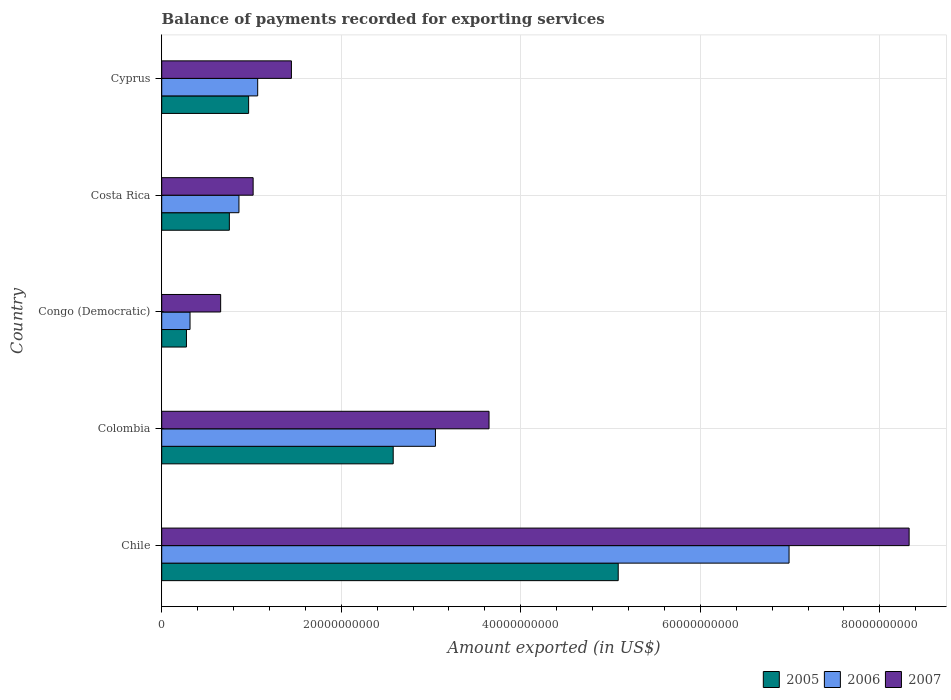How many different coloured bars are there?
Keep it short and to the point. 3. How many groups of bars are there?
Ensure brevity in your answer.  5. Are the number of bars per tick equal to the number of legend labels?
Your response must be concise. Yes. Are the number of bars on each tick of the Y-axis equal?
Your response must be concise. Yes. What is the label of the 4th group of bars from the top?
Keep it short and to the point. Colombia. What is the amount exported in 2005 in Colombia?
Your answer should be compact. 2.58e+1. Across all countries, what is the maximum amount exported in 2007?
Provide a short and direct response. 8.33e+1. Across all countries, what is the minimum amount exported in 2007?
Your answer should be very brief. 6.57e+09. In which country was the amount exported in 2007 maximum?
Your answer should be very brief. Chile. In which country was the amount exported in 2006 minimum?
Ensure brevity in your answer.  Congo (Democratic). What is the total amount exported in 2006 in the graph?
Provide a short and direct response. 1.23e+11. What is the difference between the amount exported in 2006 in Congo (Democratic) and that in Costa Rica?
Give a very brief answer. -5.45e+09. What is the difference between the amount exported in 2007 in Congo (Democratic) and the amount exported in 2005 in Colombia?
Ensure brevity in your answer.  -1.92e+1. What is the average amount exported in 2006 per country?
Offer a terse response. 2.46e+1. What is the difference between the amount exported in 2006 and amount exported in 2005 in Congo (Democratic)?
Your answer should be very brief. 4.00e+08. In how many countries, is the amount exported in 2007 greater than 72000000000 US$?
Offer a very short reply. 1. What is the ratio of the amount exported in 2007 in Colombia to that in Cyprus?
Offer a terse response. 2.52. Is the amount exported in 2006 in Chile less than that in Costa Rica?
Keep it short and to the point. No. Is the difference between the amount exported in 2006 in Costa Rica and Cyprus greater than the difference between the amount exported in 2005 in Costa Rica and Cyprus?
Your response must be concise. Yes. What is the difference between the highest and the second highest amount exported in 2006?
Offer a terse response. 3.94e+1. What is the difference between the highest and the lowest amount exported in 2005?
Offer a very short reply. 4.81e+1. In how many countries, is the amount exported in 2007 greater than the average amount exported in 2007 taken over all countries?
Provide a succinct answer. 2. Is it the case that in every country, the sum of the amount exported in 2007 and amount exported in 2005 is greater than the amount exported in 2006?
Make the answer very short. Yes. How many countries are there in the graph?
Keep it short and to the point. 5. What is the difference between two consecutive major ticks on the X-axis?
Provide a succinct answer. 2.00e+1. Does the graph contain any zero values?
Your answer should be very brief. No. How are the legend labels stacked?
Give a very brief answer. Horizontal. What is the title of the graph?
Make the answer very short. Balance of payments recorded for exporting services. What is the label or title of the X-axis?
Keep it short and to the point. Amount exported (in US$). What is the label or title of the Y-axis?
Provide a short and direct response. Country. What is the Amount exported (in US$) of 2005 in Chile?
Ensure brevity in your answer.  5.09e+1. What is the Amount exported (in US$) of 2006 in Chile?
Offer a very short reply. 6.99e+1. What is the Amount exported (in US$) in 2007 in Chile?
Provide a succinct answer. 8.33e+1. What is the Amount exported (in US$) of 2005 in Colombia?
Ensure brevity in your answer.  2.58e+1. What is the Amount exported (in US$) in 2006 in Colombia?
Keep it short and to the point. 3.05e+1. What is the Amount exported (in US$) of 2007 in Colombia?
Offer a terse response. 3.65e+1. What is the Amount exported (in US$) in 2005 in Congo (Democratic)?
Your answer should be very brief. 2.76e+09. What is the Amount exported (in US$) in 2006 in Congo (Democratic)?
Your answer should be compact. 3.16e+09. What is the Amount exported (in US$) in 2007 in Congo (Democratic)?
Your answer should be very brief. 6.57e+09. What is the Amount exported (in US$) of 2005 in Costa Rica?
Ensure brevity in your answer.  7.54e+09. What is the Amount exported (in US$) in 2006 in Costa Rica?
Keep it short and to the point. 8.60e+09. What is the Amount exported (in US$) in 2007 in Costa Rica?
Make the answer very short. 1.02e+1. What is the Amount exported (in US$) in 2005 in Cyprus?
Keep it short and to the point. 9.68e+09. What is the Amount exported (in US$) in 2006 in Cyprus?
Provide a succinct answer. 1.07e+1. What is the Amount exported (in US$) in 2007 in Cyprus?
Keep it short and to the point. 1.44e+1. Across all countries, what is the maximum Amount exported (in US$) in 2005?
Make the answer very short. 5.09e+1. Across all countries, what is the maximum Amount exported (in US$) in 2006?
Provide a short and direct response. 6.99e+1. Across all countries, what is the maximum Amount exported (in US$) of 2007?
Offer a very short reply. 8.33e+1. Across all countries, what is the minimum Amount exported (in US$) of 2005?
Offer a very short reply. 2.76e+09. Across all countries, what is the minimum Amount exported (in US$) in 2006?
Ensure brevity in your answer.  3.16e+09. Across all countries, what is the minimum Amount exported (in US$) of 2007?
Your answer should be very brief. 6.57e+09. What is the total Amount exported (in US$) of 2005 in the graph?
Make the answer very short. 9.66e+1. What is the total Amount exported (in US$) in 2006 in the graph?
Offer a very short reply. 1.23e+11. What is the total Amount exported (in US$) in 2007 in the graph?
Ensure brevity in your answer.  1.51e+11. What is the difference between the Amount exported (in US$) of 2005 in Chile and that in Colombia?
Offer a very short reply. 2.51e+1. What is the difference between the Amount exported (in US$) of 2006 in Chile and that in Colombia?
Offer a very short reply. 3.94e+1. What is the difference between the Amount exported (in US$) of 2007 in Chile and that in Colombia?
Make the answer very short. 4.68e+1. What is the difference between the Amount exported (in US$) in 2005 in Chile and that in Congo (Democratic)?
Offer a terse response. 4.81e+1. What is the difference between the Amount exported (in US$) in 2006 in Chile and that in Congo (Democratic)?
Make the answer very short. 6.67e+1. What is the difference between the Amount exported (in US$) of 2007 in Chile and that in Congo (Democratic)?
Ensure brevity in your answer.  7.67e+1. What is the difference between the Amount exported (in US$) of 2005 in Chile and that in Costa Rica?
Ensure brevity in your answer.  4.33e+1. What is the difference between the Amount exported (in US$) in 2006 in Chile and that in Costa Rica?
Keep it short and to the point. 6.13e+1. What is the difference between the Amount exported (in US$) of 2007 in Chile and that in Costa Rica?
Offer a terse response. 7.31e+1. What is the difference between the Amount exported (in US$) in 2005 in Chile and that in Cyprus?
Provide a short and direct response. 4.12e+1. What is the difference between the Amount exported (in US$) in 2006 in Chile and that in Cyprus?
Give a very brief answer. 5.92e+1. What is the difference between the Amount exported (in US$) of 2007 in Chile and that in Cyprus?
Provide a succinct answer. 6.88e+1. What is the difference between the Amount exported (in US$) in 2005 in Colombia and that in Congo (Democratic)?
Your answer should be compact. 2.30e+1. What is the difference between the Amount exported (in US$) of 2006 in Colombia and that in Congo (Democratic)?
Ensure brevity in your answer.  2.73e+1. What is the difference between the Amount exported (in US$) in 2007 in Colombia and that in Congo (Democratic)?
Give a very brief answer. 2.99e+1. What is the difference between the Amount exported (in US$) in 2005 in Colombia and that in Costa Rica?
Offer a terse response. 1.83e+1. What is the difference between the Amount exported (in US$) of 2006 in Colombia and that in Costa Rica?
Provide a short and direct response. 2.19e+1. What is the difference between the Amount exported (in US$) of 2007 in Colombia and that in Costa Rica?
Offer a terse response. 2.63e+1. What is the difference between the Amount exported (in US$) of 2005 in Colombia and that in Cyprus?
Give a very brief answer. 1.61e+1. What is the difference between the Amount exported (in US$) in 2006 in Colombia and that in Cyprus?
Give a very brief answer. 1.98e+1. What is the difference between the Amount exported (in US$) in 2007 in Colombia and that in Cyprus?
Ensure brevity in your answer.  2.20e+1. What is the difference between the Amount exported (in US$) in 2005 in Congo (Democratic) and that in Costa Rica?
Make the answer very short. -4.78e+09. What is the difference between the Amount exported (in US$) of 2006 in Congo (Democratic) and that in Costa Rica?
Keep it short and to the point. -5.45e+09. What is the difference between the Amount exported (in US$) of 2007 in Congo (Democratic) and that in Costa Rica?
Your response must be concise. -3.62e+09. What is the difference between the Amount exported (in US$) in 2005 in Congo (Democratic) and that in Cyprus?
Make the answer very short. -6.93e+09. What is the difference between the Amount exported (in US$) of 2006 in Congo (Democratic) and that in Cyprus?
Provide a succinct answer. -7.54e+09. What is the difference between the Amount exported (in US$) of 2007 in Congo (Democratic) and that in Cyprus?
Keep it short and to the point. -7.88e+09. What is the difference between the Amount exported (in US$) of 2005 in Costa Rica and that in Cyprus?
Ensure brevity in your answer.  -2.15e+09. What is the difference between the Amount exported (in US$) in 2006 in Costa Rica and that in Cyprus?
Your answer should be very brief. -2.09e+09. What is the difference between the Amount exported (in US$) of 2007 in Costa Rica and that in Cyprus?
Keep it short and to the point. -4.27e+09. What is the difference between the Amount exported (in US$) of 2005 in Chile and the Amount exported (in US$) of 2006 in Colombia?
Provide a short and direct response. 2.04e+1. What is the difference between the Amount exported (in US$) in 2005 in Chile and the Amount exported (in US$) in 2007 in Colombia?
Provide a short and direct response. 1.44e+1. What is the difference between the Amount exported (in US$) of 2006 in Chile and the Amount exported (in US$) of 2007 in Colombia?
Give a very brief answer. 3.34e+1. What is the difference between the Amount exported (in US$) in 2005 in Chile and the Amount exported (in US$) in 2006 in Congo (Democratic)?
Your answer should be very brief. 4.77e+1. What is the difference between the Amount exported (in US$) in 2005 in Chile and the Amount exported (in US$) in 2007 in Congo (Democratic)?
Your answer should be very brief. 4.43e+1. What is the difference between the Amount exported (in US$) in 2006 in Chile and the Amount exported (in US$) in 2007 in Congo (Democratic)?
Your answer should be compact. 6.33e+1. What is the difference between the Amount exported (in US$) of 2005 in Chile and the Amount exported (in US$) of 2006 in Costa Rica?
Give a very brief answer. 4.22e+1. What is the difference between the Amount exported (in US$) of 2005 in Chile and the Amount exported (in US$) of 2007 in Costa Rica?
Provide a succinct answer. 4.07e+1. What is the difference between the Amount exported (in US$) of 2006 in Chile and the Amount exported (in US$) of 2007 in Costa Rica?
Your response must be concise. 5.97e+1. What is the difference between the Amount exported (in US$) of 2005 in Chile and the Amount exported (in US$) of 2006 in Cyprus?
Ensure brevity in your answer.  4.02e+1. What is the difference between the Amount exported (in US$) of 2005 in Chile and the Amount exported (in US$) of 2007 in Cyprus?
Keep it short and to the point. 3.64e+1. What is the difference between the Amount exported (in US$) of 2006 in Chile and the Amount exported (in US$) of 2007 in Cyprus?
Give a very brief answer. 5.54e+1. What is the difference between the Amount exported (in US$) of 2005 in Colombia and the Amount exported (in US$) of 2006 in Congo (Democratic)?
Offer a very short reply. 2.26e+1. What is the difference between the Amount exported (in US$) in 2005 in Colombia and the Amount exported (in US$) in 2007 in Congo (Democratic)?
Offer a very short reply. 1.92e+1. What is the difference between the Amount exported (in US$) of 2006 in Colombia and the Amount exported (in US$) of 2007 in Congo (Democratic)?
Your answer should be compact. 2.39e+1. What is the difference between the Amount exported (in US$) of 2005 in Colombia and the Amount exported (in US$) of 2006 in Costa Rica?
Provide a short and direct response. 1.72e+1. What is the difference between the Amount exported (in US$) in 2005 in Colombia and the Amount exported (in US$) in 2007 in Costa Rica?
Your answer should be very brief. 1.56e+1. What is the difference between the Amount exported (in US$) of 2006 in Colombia and the Amount exported (in US$) of 2007 in Costa Rica?
Your answer should be compact. 2.03e+1. What is the difference between the Amount exported (in US$) of 2005 in Colombia and the Amount exported (in US$) of 2006 in Cyprus?
Make the answer very short. 1.51e+1. What is the difference between the Amount exported (in US$) of 2005 in Colombia and the Amount exported (in US$) of 2007 in Cyprus?
Give a very brief answer. 1.13e+1. What is the difference between the Amount exported (in US$) in 2006 in Colombia and the Amount exported (in US$) in 2007 in Cyprus?
Keep it short and to the point. 1.60e+1. What is the difference between the Amount exported (in US$) in 2005 in Congo (Democratic) and the Amount exported (in US$) in 2006 in Costa Rica?
Ensure brevity in your answer.  -5.85e+09. What is the difference between the Amount exported (in US$) in 2005 in Congo (Democratic) and the Amount exported (in US$) in 2007 in Costa Rica?
Provide a short and direct response. -7.43e+09. What is the difference between the Amount exported (in US$) in 2006 in Congo (Democratic) and the Amount exported (in US$) in 2007 in Costa Rica?
Keep it short and to the point. -7.03e+09. What is the difference between the Amount exported (in US$) of 2005 in Congo (Democratic) and the Amount exported (in US$) of 2006 in Cyprus?
Your answer should be compact. -7.94e+09. What is the difference between the Amount exported (in US$) of 2005 in Congo (Democratic) and the Amount exported (in US$) of 2007 in Cyprus?
Ensure brevity in your answer.  -1.17e+1. What is the difference between the Amount exported (in US$) of 2006 in Congo (Democratic) and the Amount exported (in US$) of 2007 in Cyprus?
Provide a succinct answer. -1.13e+1. What is the difference between the Amount exported (in US$) of 2005 in Costa Rica and the Amount exported (in US$) of 2006 in Cyprus?
Provide a succinct answer. -3.16e+09. What is the difference between the Amount exported (in US$) of 2005 in Costa Rica and the Amount exported (in US$) of 2007 in Cyprus?
Provide a succinct answer. -6.91e+09. What is the difference between the Amount exported (in US$) in 2006 in Costa Rica and the Amount exported (in US$) in 2007 in Cyprus?
Ensure brevity in your answer.  -5.84e+09. What is the average Amount exported (in US$) in 2005 per country?
Offer a terse response. 1.93e+1. What is the average Amount exported (in US$) of 2006 per country?
Offer a terse response. 2.46e+1. What is the average Amount exported (in US$) in 2007 per country?
Keep it short and to the point. 3.02e+1. What is the difference between the Amount exported (in US$) in 2005 and Amount exported (in US$) in 2006 in Chile?
Offer a terse response. -1.90e+1. What is the difference between the Amount exported (in US$) of 2005 and Amount exported (in US$) of 2007 in Chile?
Offer a very short reply. -3.24e+1. What is the difference between the Amount exported (in US$) of 2006 and Amount exported (in US$) of 2007 in Chile?
Make the answer very short. -1.34e+1. What is the difference between the Amount exported (in US$) in 2005 and Amount exported (in US$) in 2006 in Colombia?
Provide a short and direct response. -4.70e+09. What is the difference between the Amount exported (in US$) in 2005 and Amount exported (in US$) in 2007 in Colombia?
Give a very brief answer. -1.07e+1. What is the difference between the Amount exported (in US$) of 2006 and Amount exported (in US$) of 2007 in Colombia?
Offer a very short reply. -5.97e+09. What is the difference between the Amount exported (in US$) in 2005 and Amount exported (in US$) in 2006 in Congo (Democratic)?
Give a very brief answer. -4.00e+08. What is the difference between the Amount exported (in US$) of 2005 and Amount exported (in US$) of 2007 in Congo (Democratic)?
Your response must be concise. -3.81e+09. What is the difference between the Amount exported (in US$) in 2006 and Amount exported (in US$) in 2007 in Congo (Democratic)?
Your answer should be compact. -3.41e+09. What is the difference between the Amount exported (in US$) in 2005 and Amount exported (in US$) in 2006 in Costa Rica?
Give a very brief answer. -1.07e+09. What is the difference between the Amount exported (in US$) in 2005 and Amount exported (in US$) in 2007 in Costa Rica?
Your response must be concise. -2.65e+09. What is the difference between the Amount exported (in US$) in 2006 and Amount exported (in US$) in 2007 in Costa Rica?
Provide a short and direct response. -1.58e+09. What is the difference between the Amount exported (in US$) of 2005 and Amount exported (in US$) of 2006 in Cyprus?
Your response must be concise. -1.01e+09. What is the difference between the Amount exported (in US$) in 2005 and Amount exported (in US$) in 2007 in Cyprus?
Keep it short and to the point. -4.77e+09. What is the difference between the Amount exported (in US$) in 2006 and Amount exported (in US$) in 2007 in Cyprus?
Keep it short and to the point. -3.76e+09. What is the ratio of the Amount exported (in US$) in 2005 in Chile to that in Colombia?
Ensure brevity in your answer.  1.97. What is the ratio of the Amount exported (in US$) in 2006 in Chile to that in Colombia?
Your response must be concise. 2.29. What is the ratio of the Amount exported (in US$) of 2007 in Chile to that in Colombia?
Offer a terse response. 2.28. What is the ratio of the Amount exported (in US$) in 2005 in Chile to that in Congo (Democratic)?
Provide a succinct answer. 18.46. What is the ratio of the Amount exported (in US$) in 2006 in Chile to that in Congo (Democratic)?
Provide a succinct answer. 22.15. What is the ratio of the Amount exported (in US$) of 2007 in Chile to that in Congo (Democratic)?
Ensure brevity in your answer.  12.68. What is the ratio of the Amount exported (in US$) in 2005 in Chile to that in Costa Rica?
Your answer should be compact. 6.75. What is the ratio of the Amount exported (in US$) in 2006 in Chile to that in Costa Rica?
Offer a very short reply. 8.12. What is the ratio of the Amount exported (in US$) of 2007 in Chile to that in Costa Rica?
Make the answer very short. 8.18. What is the ratio of the Amount exported (in US$) of 2005 in Chile to that in Cyprus?
Provide a succinct answer. 5.25. What is the ratio of the Amount exported (in US$) of 2006 in Chile to that in Cyprus?
Keep it short and to the point. 6.54. What is the ratio of the Amount exported (in US$) of 2007 in Chile to that in Cyprus?
Your response must be concise. 5.76. What is the ratio of the Amount exported (in US$) in 2005 in Colombia to that in Congo (Democratic)?
Make the answer very short. 9.36. What is the ratio of the Amount exported (in US$) of 2006 in Colombia to that in Congo (Democratic)?
Your response must be concise. 9.66. What is the ratio of the Amount exported (in US$) in 2007 in Colombia to that in Congo (Democratic)?
Your answer should be compact. 5.55. What is the ratio of the Amount exported (in US$) of 2005 in Colombia to that in Costa Rica?
Provide a short and direct response. 3.42. What is the ratio of the Amount exported (in US$) in 2006 in Colombia to that in Costa Rica?
Your answer should be very brief. 3.54. What is the ratio of the Amount exported (in US$) of 2007 in Colombia to that in Costa Rica?
Offer a very short reply. 3.58. What is the ratio of the Amount exported (in US$) of 2005 in Colombia to that in Cyprus?
Your answer should be very brief. 2.66. What is the ratio of the Amount exported (in US$) in 2006 in Colombia to that in Cyprus?
Your answer should be compact. 2.85. What is the ratio of the Amount exported (in US$) of 2007 in Colombia to that in Cyprus?
Your answer should be very brief. 2.52. What is the ratio of the Amount exported (in US$) in 2005 in Congo (Democratic) to that in Costa Rica?
Your response must be concise. 0.37. What is the ratio of the Amount exported (in US$) of 2006 in Congo (Democratic) to that in Costa Rica?
Keep it short and to the point. 0.37. What is the ratio of the Amount exported (in US$) in 2007 in Congo (Democratic) to that in Costa Rica?
Your response must be concise. 0.64. What is the ratio of the Amount exported (in US$) in 2005 in Congo (Democratic) to that in Cyprus?
Your answer should be compact. 0.28. What is the ratio of the Amount exported (in US$) of 2006 in Congo (Democratic) to that in Cyprus?
Offer a terse response. 0.3. What is the ratio of the Amount exported (in US$) of 2007 in Congo (Democratic) to that in Cyprus?
Offer a very short reply. 0.45. What is the ratio of the Amount exported (in US$) in 2005 in Costa Rica to that in Cyprus?
Provide a succinct answer. 0.78. What is the ratio of the Amount exported (in US$) in 2006 in Costa Rica to that in Cyprus?
Give a very brief answer. 0.8. What is the ratio of the Amount exported (in US$) of 2007 in Costa Rica to that in Cyprus?
Give a very brief answer. 0.7. What is the difference between the highest and the second highest Amount exported (in US$) of 2005?
Your answer should be very brief. 2.51e+1. What is the difference between the highest and the second highest Amount exported (in US$) of 2006?
Ensure brevity in your answer.  3.94e+1. What is the difference between the highest and the second highest Amount exported (in US$) of 2007?
Offer a very short reply. 4.68e+1. What is the difference between the highest and the lowest Amount exported (in US$) in 2005?
Offer a terse response. 4.81e+1. What is the difference between the highest and the lowest Amount exported (in US$) of 2006?
Your answer should be compact. 6.67e+1. What is the difference between the highest and the lowest Amount exported (in US$) of 2007?
Keep it short and to the point. 7.67e+1. 